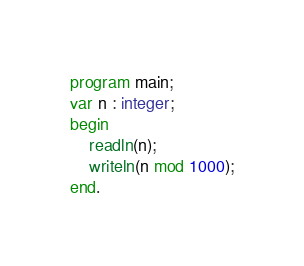<code> <loc_0><loc_0><loc_500><loc_500><_Pascal_>program main;
var n : integer;
begin
	readln(n);
    writeln(n mod 1000);
end.    </code> 